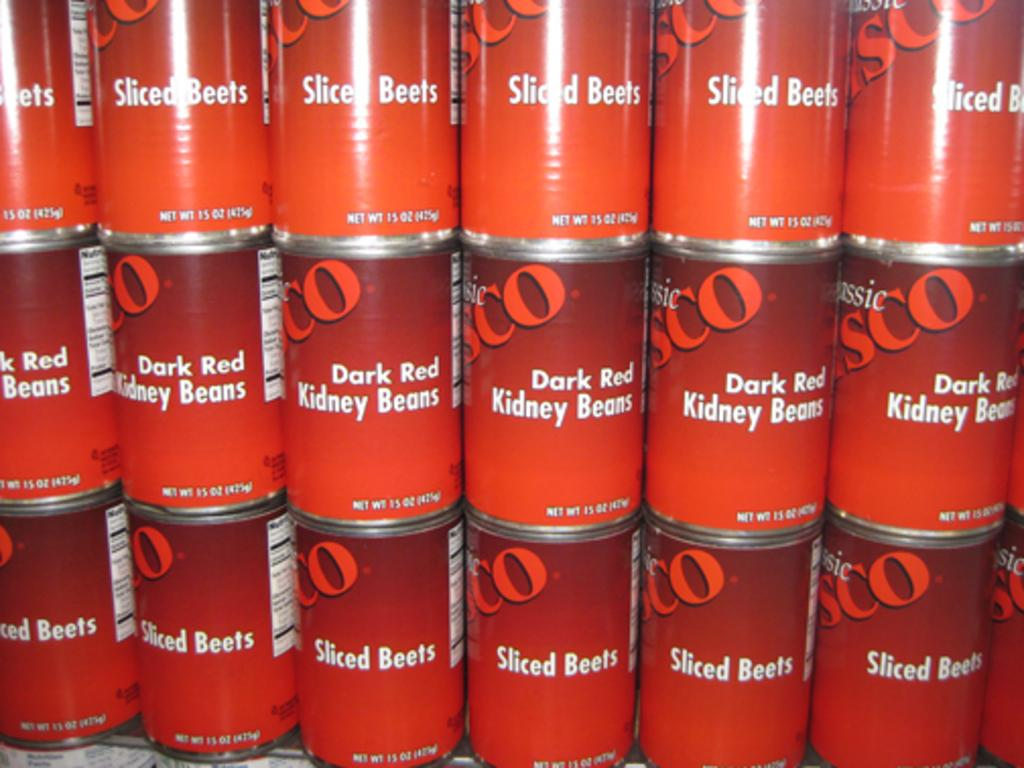<image>
Summarize the visual content of the image. Several stacks of can with a label dark red kidney beans. 